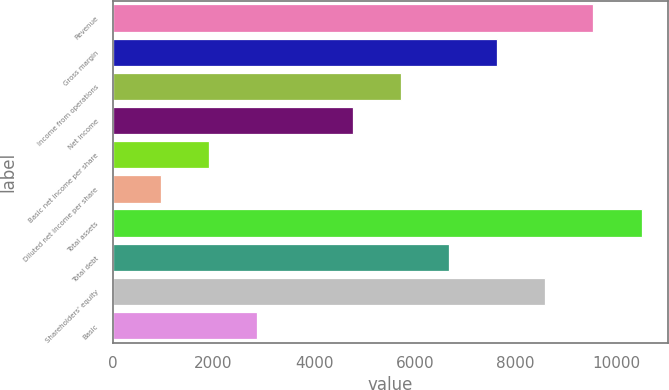Convert chart. <chart><loc_0><loc_0><loc_500><loc_500><bar_chart><fcel>Revenue<fcel>Gross margin<fcel>Income from operations<fcel>Net income<fcel>Basic net income per share<fcel>Diluted net income per share<fcel>Total assets<fcel>Total debt<fcel>Shareholders' equity<fcel>Basic<nl><fcel>9544.02<fcel>7635.28<fcel>5726.54<fcel>4772.17<fcel>1909.06<fcel>954.69<fcel>10498.4<fcel>6680.91<fcel>8589.65<fcel>2863.43<nl></chart> 